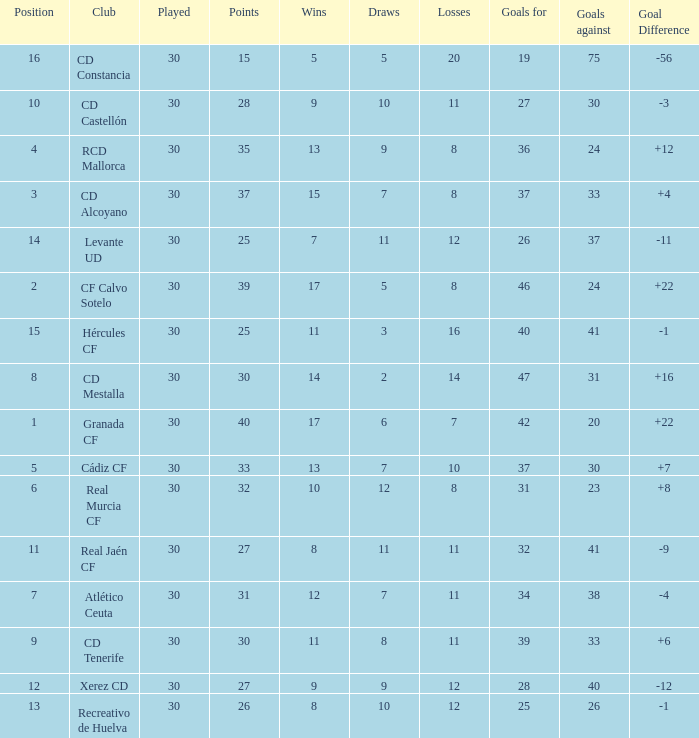How many Draws have 30 Points, and less than 33 Goals against? 1.0. 